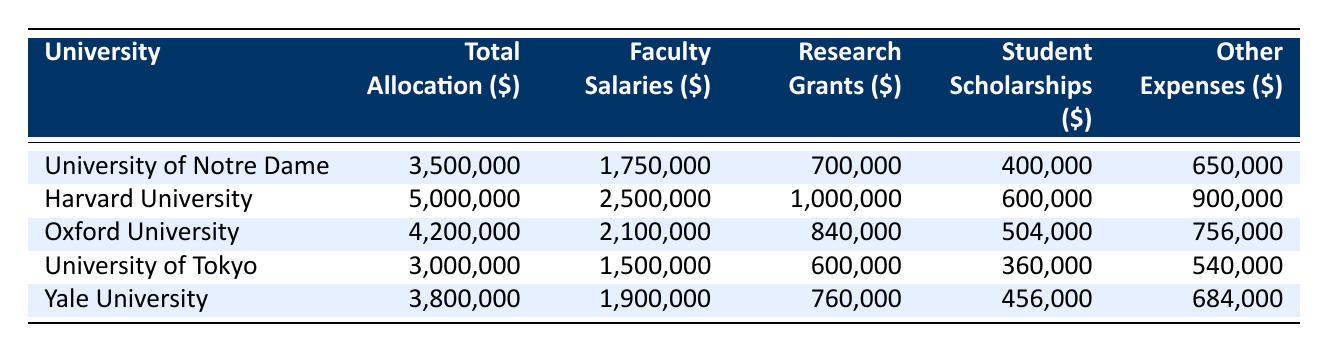What's the total allocation for Harvard University? The total allocation for Harvard University is located in the second row of the table under the "Total Allocation" column. Looking at this specific entry, the total allocation is 5,000,000 dollars.
Answer: 5,000,000 Which university has the highest faculty salaries? By examining the "Faculty Salaries" column, we find the highest value corresponds to Harvard University with salaries amounting to 2,500,000 dollars.
Answer: Harvard University What is the combined total allocation of the University of Notre Dame and Yale University? To find the combined total allocation, we first identify the total allocations for both universities: Notre Dame has 3,500,000 and Yale has 3,800,000. Adding these amounts gives 3,500,000 + 3,800,000 = 7,300,000.
Answer: 7,300,000 Does Oxford University allocate more for research grants than the University of Tokyo? Oxford University has research grants amounting to 840,000 dollars, while the University of Tokyo allocates 600,000 dollars. Since 840,000 is greater than 600,000, the statement is true.
Answer: Yes What is the average student scholarship allocation across all universities? To calculate the average, we sum the student scholarship amounts: 400,000 (Notre Dame) + 600,000 (Harvard) + 504,000 (Oxford) + 360,000 (Tokyo) + 456,000 (Yale) = 2,320,000. There are 5 universities, so the average is 2,320,000 / 5 = 464,000.
Answer: 464,000 Based on the table, is it true that the University of Tokyo has the lowest total allocation? By comparing the total allocations, we list them: 3,500,000 (Notre Dame), 5,000,000 (Harvard), 4,200,000 (Oxford), 3,000,000 (Tokyo), and 3,800,000 (Yale). The total allocation for the University of Tokyo at 3,000,000 is indeed the lowest.
Answer: Yes What is the total amount allocated to events and conferences across all universities? We can find the total by adding the event allocations: 150,000 (Notre Dame) + 250,000 (Harvard) + 252,000 (Oxford) + 120,000 (Tokyo) + 152,000 (Yale) = 924,000.
Answer: 924,000 Which university spends the least on library resources? The library resources expenditures are as follows: 200,000 (Notre Dame), 350,000 (Harvard), 294,000 (Oxford), 180,000 (Tokyo), and 266,000 (Yale). The lowest amount is found at the University of Tokyo with 180,000 dollars.
Answer: University of Tokyo 